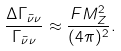Convert formula to latex. <formula><loc_0><loc_0><loc_500><loc_500>\frac { \Delta \Gamma _ { \bar { \nu } \nu } } { \Gamma _ { \bar { \nu } \nu } } \approx \frac { F M _ { Z } ^ { 2 } } { ( 4 \pi ) ^ { 2 } } .</formula> 